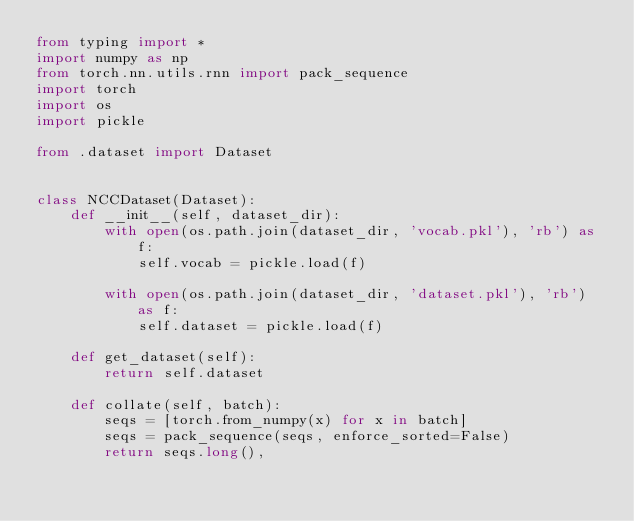Convert code to text. <code><loc_0><loc_0><loc_500><loc_500><_Python_>from typing import *
import numpy as np
from torch.nn.utils.rnn import pack_sequence
import torch
import os
import pickle

from .dataset import Dataset


class NCCDataset(Dataset):
    def __init__(self, dataset_dir):
        with open(os.path.join(dataset_dir, 'vocab.pkl'), 'rb') as f:
            self.vocab = pickle.load(f)
        
        with open(os.path.join(dataset_dir, 'dataset.pkl'), 'rb') as f:
            self.dataset = pickle.load(f)

    def get_dataset(self):
        return self.dataset

    def collate(self, batch):
        seqs = [torch.from_numpy(x) for x in batch]
        seqs = pack_sequence(seqs, enforce_sorted=False)
        return seqs.long(),
</code> 